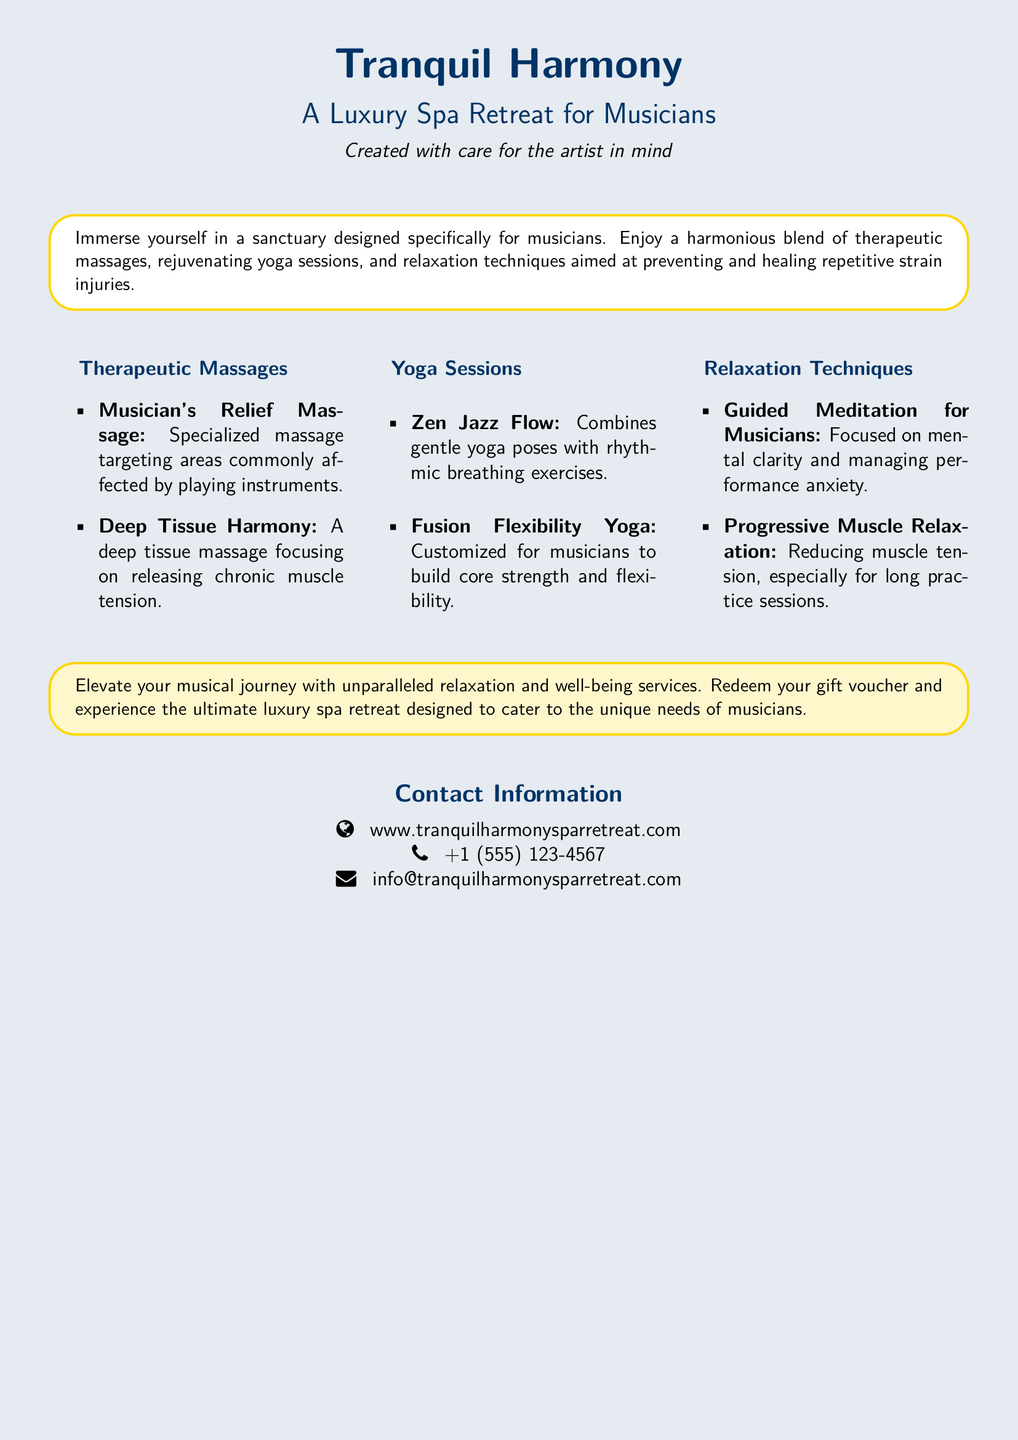what is the name of the spa retreat? The name of the spa retreat is prominently featured at the top of the document.
Answer: Tranquil Harmony what type of massages are offered? The document lists specific types of massages provided at the retreat.
Answer: Therapeutic Massages what is the phone number for contact? The contact information section includes a phone number.
Answer: +1 (555) 123-4567 what is the focus of the Zen Jazz Flow session? The description of Zen Jazz Flow specifies its combining elements.
Answer: Gentle yoga poses with rhythmic breathing exercises how many types of relaxation techniques are mentioned? A distinct section outlines the relaxation techniques available.
Answer: Two which massage targets areas affected by playing instruments? The description indicates a specific massage focusing on musicians' needs.
Answer: Musician's Relief Massage what is the URL for the spa retreat? The contact information section contains the website address.
Answer: www.tranquilharmonysparretreat.com what is the purpose of the Relaxation Techniques section? This section aims to inform about managing physical and mental tension.
Answer: Preventing and healing repetitive strain injuries how many columns are used to display service types? The document organizes service types into specific sections displayed across three visual segments.
Answer: Three 